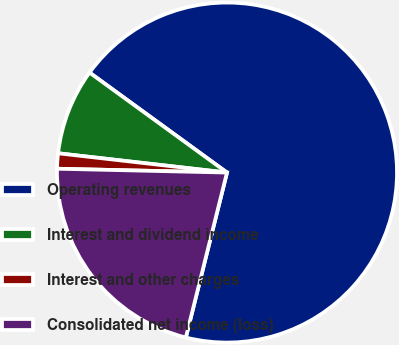Convert chart to OTSL. <chart><loc_0><loc_0><loc_500><loc_500><pie_chart><fcel>Operating revenues<fcel>Interest and dividend income<fcel>Interest and other charges<fcel>Consolidated net income (loss)<nl><fcel>68.89%<fcel>8.2%<fcel>1.45%<fcel>21.47%<nl></chart> 